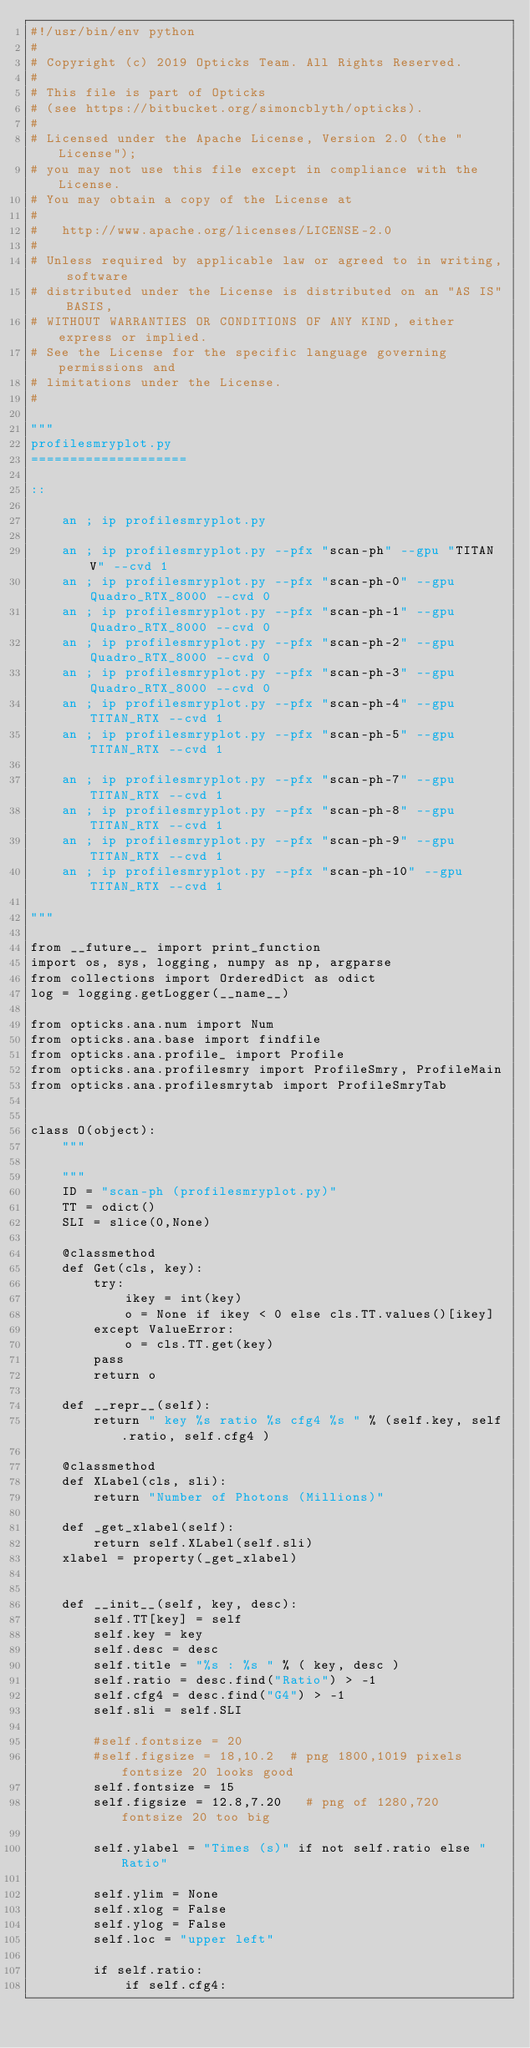<code> <loc_0><loc_0><loc_500><loc_500><_Python_>#!/usr/bin/env python
#
# Copyright (c) 2019 Opticks Team. All Rights Reserved.
#
# This file is part of Opticks
# (see https://bitbucket.org/simoncblyth/opticks).
#
# Licensed under the Apache License, Version 2.0 (the "License"); 
# you may not use this file except in compliance with the License.  
# You may obtain a copy of the License at
#
#   http://www.apache.org/licenses/LICENSE-2.0
#
# Unless required by applicable law or agreed to in writing, software 
# distributed under the License is distributed on an "AS IS" BASIS, 
# WITHOUT WARRANTIES OR CONDITIONS OF ANY KIND, either express or implied.  
# See the License for the specific language governing permissions and 
# limitations under the License.
#

"""
profilesmryplot.py
====================

::

    an ; ip profilesmryplot.py

    an ; ip profilesmryplot.py --pfx "scan-ph" --gpu "TITAN V" --cvd 1 
    an ; ip profilesmryplot.py --pfx "scan-ph-0" --gpu Quadro_RTX_8000 --cvd 0 
    an ; ip profilesmryplot.py --pfx "scan-ph-1" --gpu Quadro_RTX_8000 --cvd 0 
    an ; ip profilesmryplot.py --pfx "scan-ph-2" --gpu Quadro_RTX_8000 --cvd 0 
    an ; ip profilesmryplot.py --pfx "scan-ph-3" --gpu Quadro_RTX_8000 --cvd 0 
    an ; ip profilesmryplot.py --pfx "scan-ph-4" --gpu TITAN_RTX --cvd 1 
    an ; ip profilesmryplot.py --pfx "scan-ph-5" --gpu TITAN_RTX --cvd 1 

    an ; ip profilesmryplot.py --pfx "scan-ph-7" --gpu TITAN_RTX --cvd 1 
    an ; ip profilesmryplot.py --pfx "scan-ph-8" --gpu TITAN_RTX --cvd 1 
    an ; ip profilesmryplot.py --pfx "scan-ph-9" --gpu TITAN_RTX --cvd 1 
    an ; ip profilesmryplot.py --pfx "scan-ph-10" --gpu TITAN_RTX --cvd 1 

"""

from __future__ import print_function
import os, sys, logging, numpy as np, argparse
from collections import OrderedDict as odict
log = logging.getLogger(__name__)

from opticks.ana.num import Num
from opticks.ana.base import findfile
from opticks.ana.profile_ import Profile
from opticks.ana.profilesmry import ProfileSmry, ProfileMain
from opticks.ana.profilesmrytab import ProfileSmryTab


class O(object):
    """

    """
    ID = "scan-ph (profilesmryplot.py)"
    TT = odict()
    SLI = slice(0,None)

    @classmethod
    def Get(cls, key):
        try:
            ikey = int(key)
            o = None if ikey < 0 else cls.TT.values()[ikey]
        except ValueError:
            o = cls.TT.get(key)
        pass
        return o 

    def __repr__(self):
        return " key %s ratio %s cfg4 %s " % (self.key, self.ratio, self.cfg4 ) 

    @classmethod
    def XLabel(cls, sli):
        return "Number of Photons (Millions)"

    def _get_xlabel(self):
        return self.XLabel(self.sli)
    xlabel = property(_get_xlabel)


    def __init__(self, key, desc):
        self.TT[key] = self
        self.key = key
        self.desc = desc
        self.title = "%s : %s " % ( key, desc )
        self.ratio = desc.find("Ratio") > -1  
        self.cfg4 = desc.find("G4") > -1 
        self.sli = self.SLI

        #self.fontsize = 20
        #self.figsize = 18,10.2  # png 1800,1019 pixels fontsize 20 looks good 
        self.fontsize = 15  
        self.figsize = 12.8,7.20   # png of 1280,720   fontsize 20 too big 

        self.ylabel = "Times (s)" if not self.ratio else "Ratio"

        self.ylim = None
        self.xlog = False
        self.ylog = False
        self.loc = "upper left"

        if self.ratio:
            if self.cfg4:</code> 